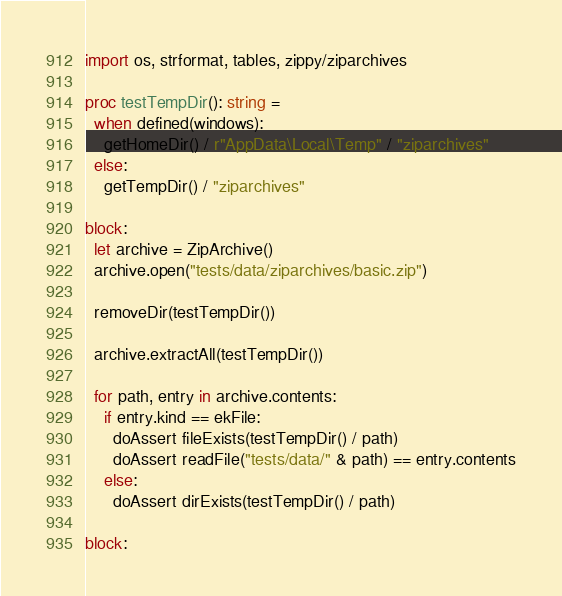<code> <loc_0><loc_0><loc_500><loc_500><_Nim_>import os, strformat, tables, zippy/ziparchives

proc testTempDir(): string =
  when defined(windows):
    getHomeDir() / r"AppData\Local\Temp" / "ziparchives"
  else:
    getTempDir() / "ziparchives"

block:
  let archive = ZipArchive()
  archive.open("tests/data/ziparchives/basic.zip")

  removeDir(testTempDir())

  archive.extractAll(testTempDir())

  for path, entry in archive.contents:
    if entry.kind == ekFile:
      doAssert fileExists(testTempDir() / path)
      doAssert readFile("tests/data/" & path) == entry.contents
    else:
      doAssert dirExists(testTempDir() / path)

block:</code> 